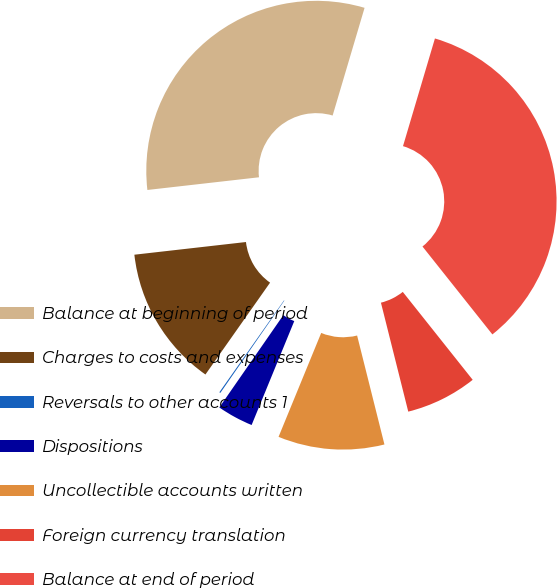Convert chart. <chart><loc_0><loc_0><loc_500><loc_500><pie_chart><fcel>Balance at beginning of period<fcel>Charges to costs and expenses<fcel>Reversals to other accounts 1<fcel>Dispositions<fcel>Uncollectible accounts written<fcel>Foreign currency translation<fcel>Balance at end of period<nl><fcel>31.39%<fcel>13.44%<fcel>0.11%<fcel>3.45%<fcel>10.11%<fcel>6.78%<fcel>34.72%<nl></chart> 